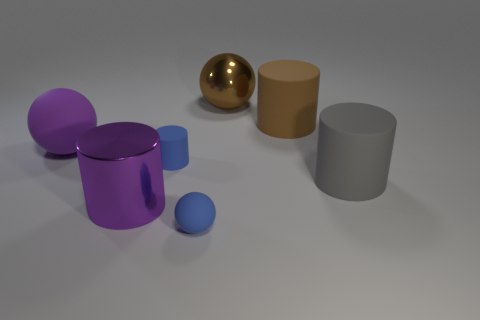There is a big purple shiny object; is it the same shape as the rubber object that is in front of the gray object?
Give a very brief answer. No. There is a shiny object that is the same shape as the big brown matte object; what size is it?
Offer a terse response. Large. There is a small ball; is its color the same as the rubber cylinder that is left of the brown rubber cylinder?
Your answer should be very brief. Yes. How many other objects are there of the same size as the blue ball?
Keep it short and to the point. 1. There is a small blue thing behind the small matte thing that is right of the matte cylinder left of the small blue matte sphere; what shape is it?
Keep it short and to the point. Cylinder. There is a metal ball; is it the same size as the rubber cylinder on the left side of the brown sphere?
Offer a terse response. No. What color is the ball that is in front of the large brown metallic thing and behind the small sphere?
Make the answer very short. Purple. How many other objects are there of the same shape as the large gray rubber object?
Provide a short and direct response. 3. Is the color of the metal object in front of the big brown matte object the same as the large sphere to the left of the blue cylinder?
Offer a very short reply. Yes. There is a brown thing to the right of the metal sphere; does it have the same size as the rubber ball that is in front of the gray cylinder?
Ensure brevity in your answer.  No. 